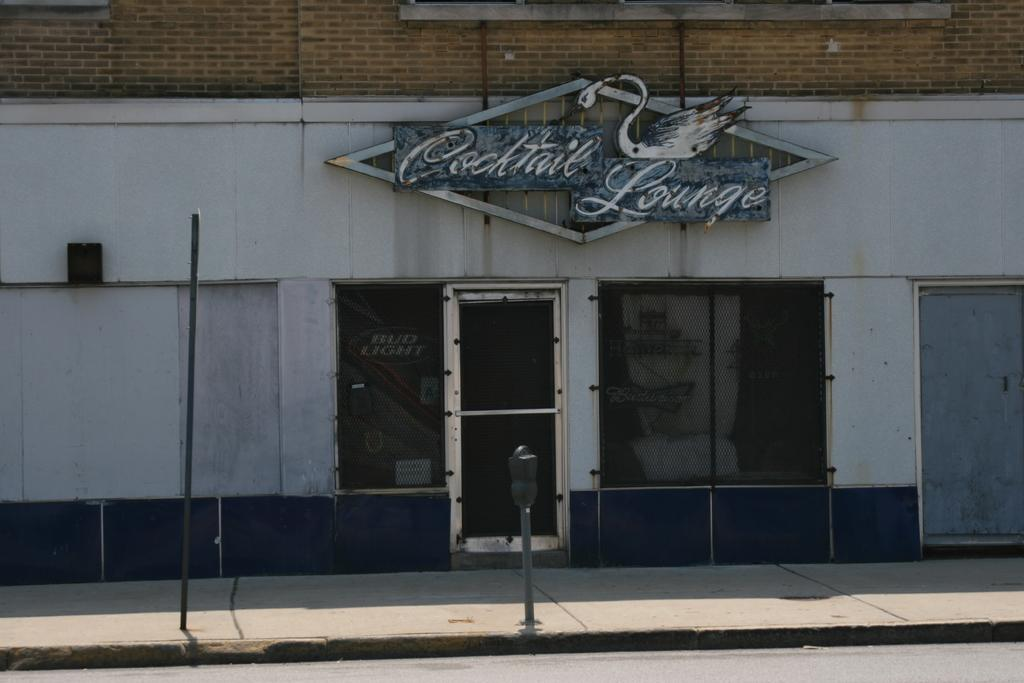What structure is present in the image? There is a building in the image. What feature of the building can be seen in the image? The building has a name board. What is the primary entrance to the building? The building has a door. What objects are in front of the building? There are a few poles in front of the building. What type of business is being conducted inside the building in the image? There is no indication of the type of business being conducted inside the building in the image. What is the texture of the poles in front of the building? The texture of the poles cannot be determined from the image alone. 